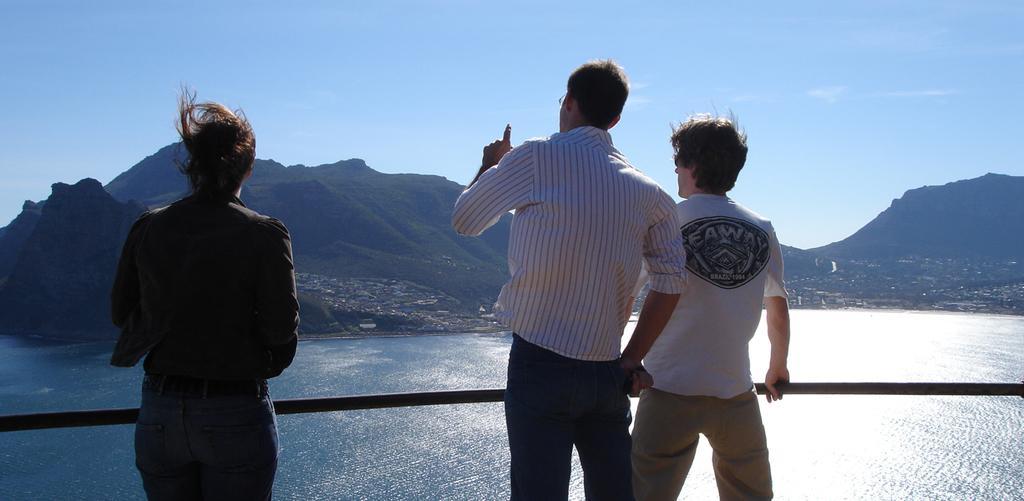How would you summarize this image in a sentence or two? In this image I can see three persons are standing near the fence. In the background I can see a lake, houses, trees and mountains. At the top I can see the sky. This image is taken during a day. 